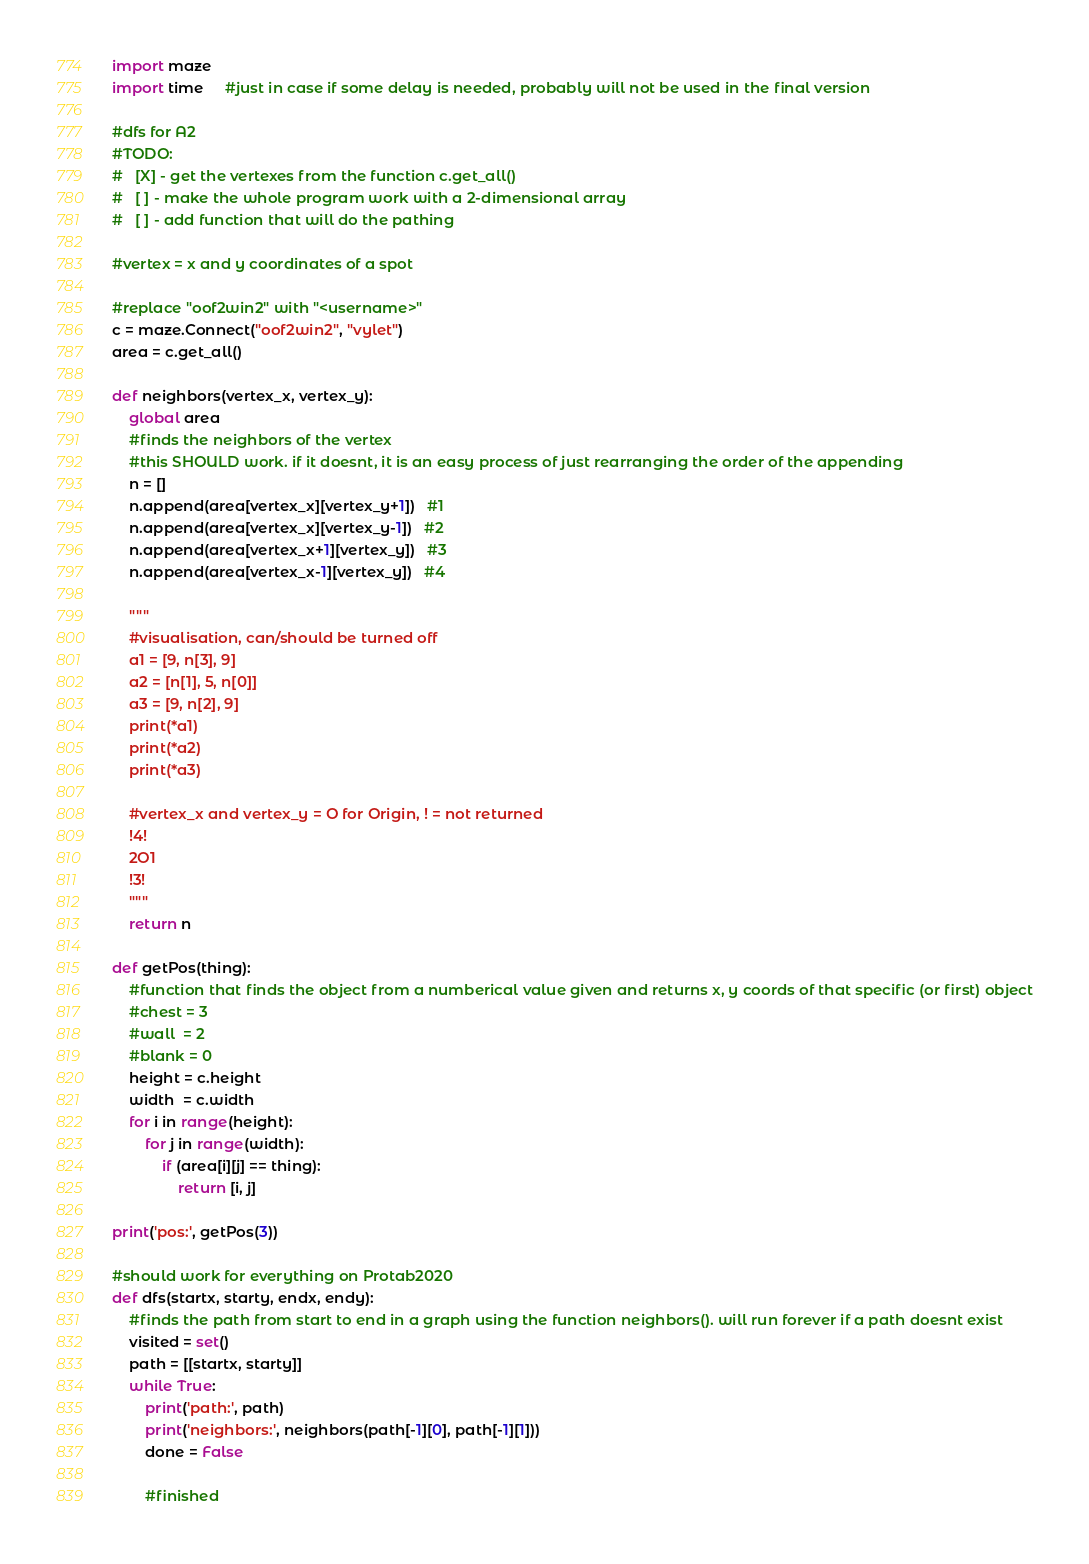Convert code to text. <code><loc_0><loc_0><loc_500><loc_500><_Python_>import maze
import time     #just in case if some delay is needed, probably will not be used in the final version

#dfs for A2
#TODO:
#   [X] - get the vertexes from the function c.get_all()
#   [ ] - make the whole program work with a 2-dimensional array
#   [ ] - add function that will do the pathing

#vertex = x and y coordinates of a spot

#replace "oof2win2" with "<username>"
c = maze.Connect("oof2win2", "vylet")
area = c.get_all()

def neighbors(vertex_x, vertex_y):
    global area
    #finds the neighbors of the vertex
    #this SHOULD work. if it doesnt, it is an easy process of just rearranging the order of the appending
    n = []
    n.append(area[vertex_x][vertex_y+1])   #1
    n.append(area[vertex_x][vertex_y-1])   #2
    n.append(area[vertex_x+1][vertex_y])   #3
    n.append(area[vertex_x-1][vertex_y])   #4

    """
    #visualisation, can/should be turned off
    a1 = [9, n[3], 9]
    a2 = [n[1], 5, n[0]]
    a3 = [9, n[2], 9]
    print(*a1)
    print(*a2)
    print(*a3)
    
    #vertex_x and vertex_y = O for Origin, ! = not returned
    !4!
    2O1
    !3!
    """
    return n

def getPos(thing):
    #function that finds the object from a numberical value given and returns x, y coords of that specific (or first) object
    #chest = 3
    #wall  = 2
    #blank = 0
    height = c.height
    width  = c.width
    for i in range(height):
        for j in range(width):
            if (area[i][j] == thing):
                return [i, j]

print('pos:', getPos(3))

#should work for everything on Protab2020
def dfs(startx, starty, endx, endy):
    #finds the path from start to end in a graph using the function neighbors(). will run forever if a path doesnt exist
    visited = set()
    path = [[startx, starty]]
    while True:
        print('path:', path)
        print('neighbors:', neighbors(path[-1][0], path[-1][1]))
        done = False

        #finished</code> 